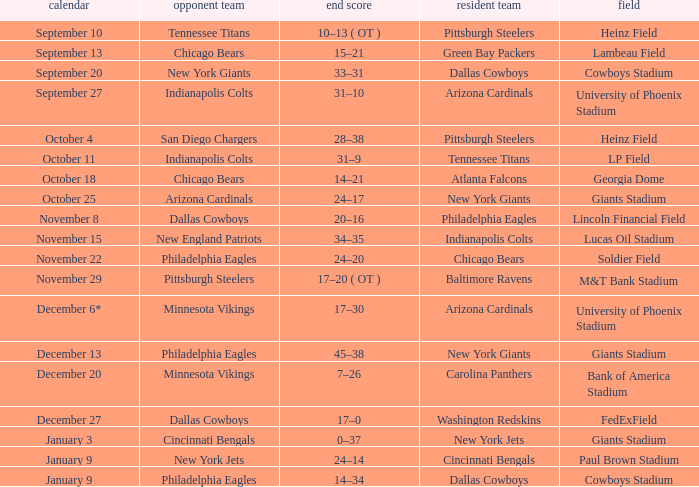I want to know the final score for december 27 17–0. 